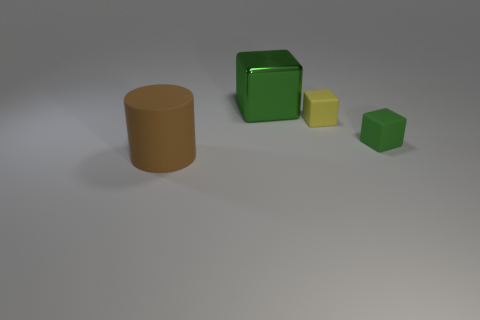Add 1 small green rubber cubes. How many objects exist? 5 Subtract all cylinders. How many objects are left? 3 Subtract 0 green cylinders. How many objects are left? 4 Subtract all yellow rubber cubes. Subtract all big rubber cylinders. How many objects are left? 2 Add 4 matte cylinders. How many matte cylinders are left? 5 Add 4 big blue metallic things. How many big blue metallic things exist? 4 